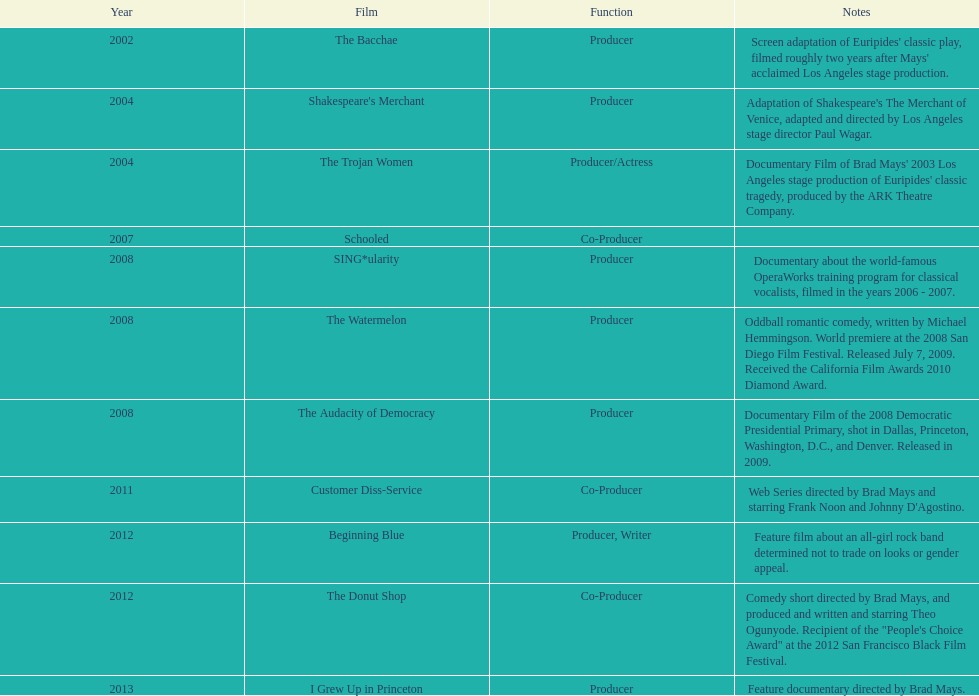Which year was there at least three movies? 2008. 